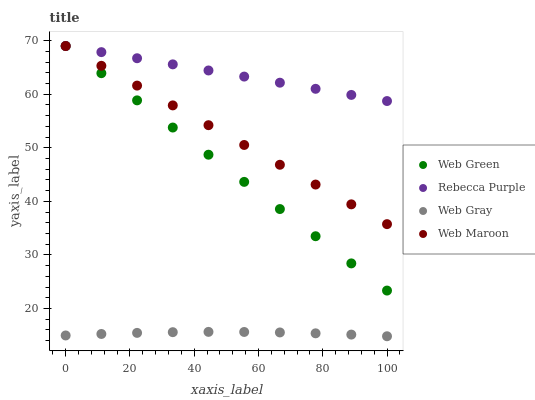Does Web Gray have the minimum area under the curve?
Answer yes or no. Yes. Does Rebecca Purple have the maximum area under the curve?
Answer yes or no. Yes. Does Web Maroon have the minimum area under the curve?
Answer yes or no. No. Does Web Maroon have the maximum area under the curve?
Answer yes or no. No. Is Web Green the smoothest?
Answer yes or no. Yes. Is Web Gray the roughest?
Answer yes or no. Yes. Is Web Maroon the smoothest?
Answer yes or no. No. Is Web Maroon the roughest?
Answer yes or no. No. Does Web Gray have the lowest value?
Answer yes or no. Yes. Does Web Maroon have the lowest value?
Answer yes or no. No. Does Web Green have the highest value?
Answer yes or no. Yes. Is Web Gray less than Rebecca Purple?
Answer yes or no. Yes. Is Rebecca Purple greater than Web Gray?
Answer yes or no. Yes. Does Web Maroon intersect Rebecca Purple?
Answer yes or no. Yes. Is Web Maroon less than Rebecca Purple?
Answer yes or no. No. Is Web Maroon greater than Rebecca Purple?
Answer yes or no. No. Does Web Gray intersect Rebecca Purple?
Answer yes or no. No. 